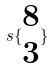<formula> <loc_0><loc_0><loc_500><loc_500>s \{ \begin{matrix} 8 \\ 3 \end{matrix} \}</formula> 